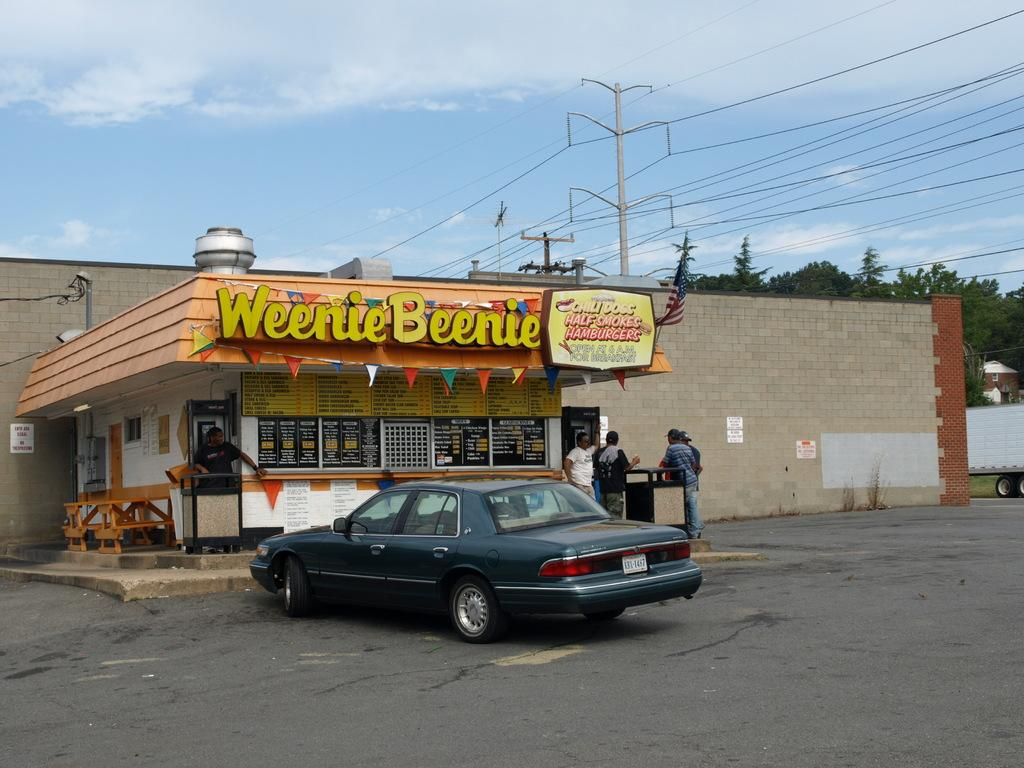What is the main subject in the center of the image? There is a car in the center of the image. What else can be seen in the center of the image besides the car? There is a stall and people standing in the center of the image. What type of bun is being served at the stall in the image? There is no bun present at the stall in the image. Can you describe the smiles on the faces of the people in the image? The provided facts do not mention any smiles on the faces of the people in the image. 